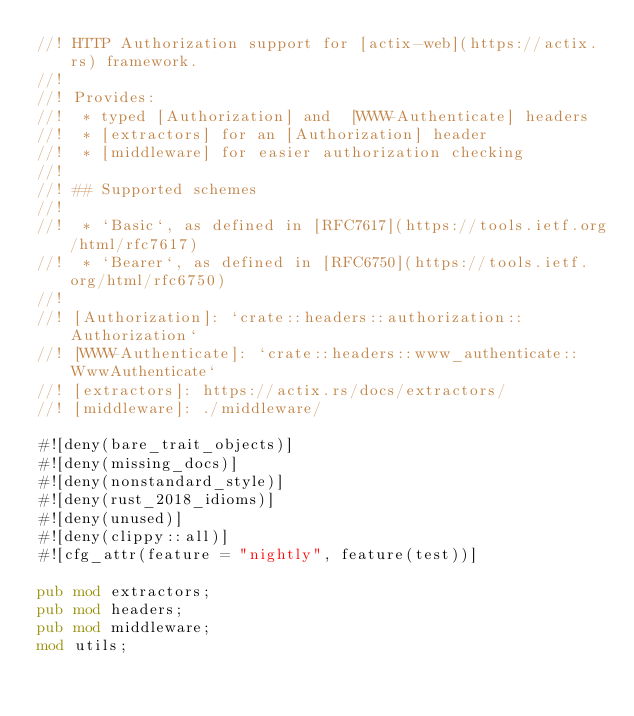<code> <loc_0><loc_0><loc_500><loc_500><_Rust_>//! HTTP Authorization support for [actix-web](https://actix.rs) framework.
//!
//! Provides:
//!  * typed [Authorization] and  [WWW-Authenticate] headers
//!  * [extractors] for an [Authorization] header
//!  * [middleware] for easier authorization checking
//!
//! ## Supported schemes
//!
//!  * `Basic`, as defined in [RFC7617](https://tools.ietf.org/html/rfc7617)
//!  * `Bearer`, as defined in [RFC6750](https://tools.ietf.org/html/rfc6750)
//!
//! [Authorization]: `crate::headers::authorization::Authorization`
//! [WWW-Authenticate]: `crate::headers::www_authenticate::WwwAuthenticate`
//! [extractors]: https://actix.rs/docs/extractors/
//! [middleware]: ./middleware/

#![deny(bare_trait_objects)]
#![deny(missing_docs)]
#![deny(nonstandard_style)]
#![deny(rust_2018_idioms)]
#![deny(unused)]
#![deny(clippy::all)]
#![cfg_attr(feature = "nightly", feature(test))]

pub mod extractors;
pub mod headers;
pub mod middleware;
mod utils;
</code> 